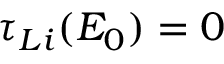Convert formula to latex. <formula><loc_0><loc_0><loc_500><loc_500>\tau _ { L i } ( E _ { 0 } ) = 0</formula> 